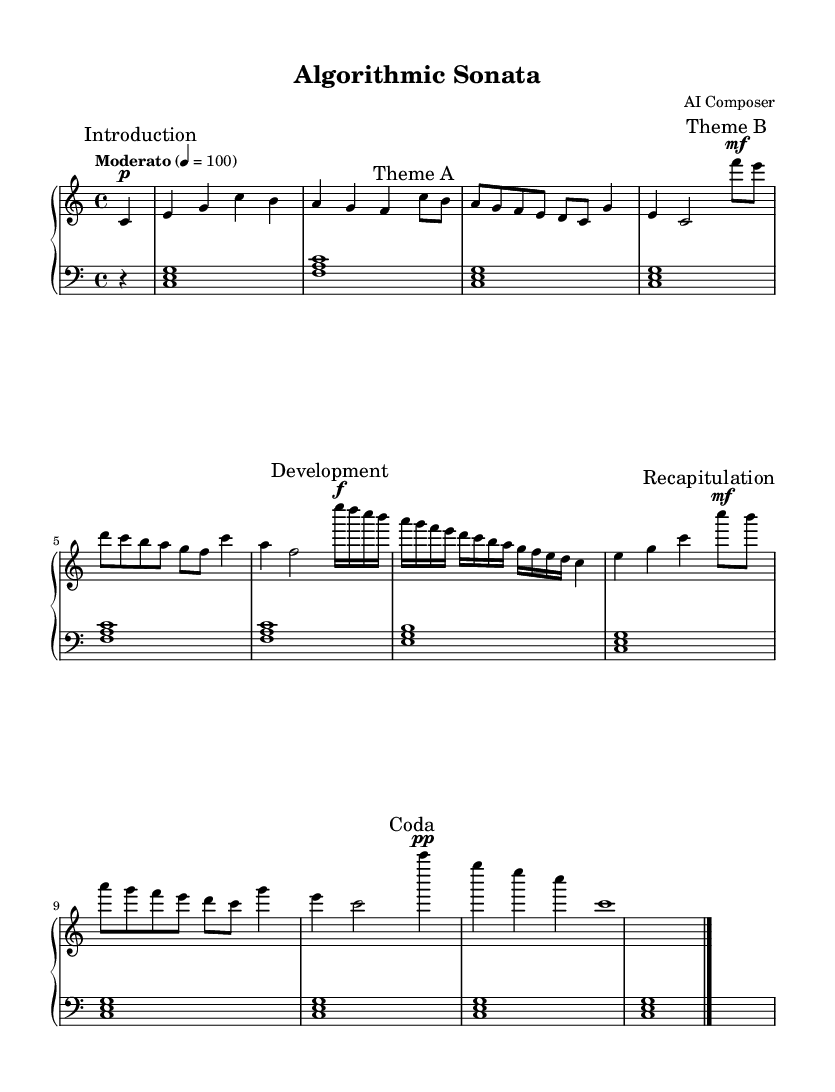What is the key signature of this music? The key signature of the piece is C major, which has no sharps or flats. This can be identified by the absence of any accidentals at the beginning of the staff, indicating it is in its natural state.
Answer: C major What is the time signature of the composition? The time signature is 4/4, which can be observed at the beginning of the music where it is clearly marked. This indicates there are four beats in each measure and the quarter note receives one beat.
Answer: 4/4 What is the tempo marking of the piece? The tempo marking indicated at the beginning of the score is "Moderato" with a metronome marking of 100 beats per minute. This description conveys the pace at which the piece should be played.
Answer: Moderato How many themes are presented in the composition? There are two distinct themes presented in the score: Theme A and Theme B. Each theme can be distinguished by their respective markings that indicate where they start in the sheet music.
Answer: Two Which section comes after the Development? The section that follows the Development is the Recapitulation, as denoted by its marking in the sheet music. The Recapitulation often revisits earlier themes after the development has taken place.
Answer: Recapitulation What is the dynamic marking for Theme B? The dynamic marking for Theme B is marked as "mf", which stands for mezzo-forte, indicating that this section should be played moderately loud. This marking is placed before the music notes for that section.
Answer: mf What chords are used in the Introduction? The chords used in the Introduction are C major, F major, and G major. These chords are represented by the notes played in the left hand and can be identified by their specific groupings in the score.
Answer: C major, F major, G major 